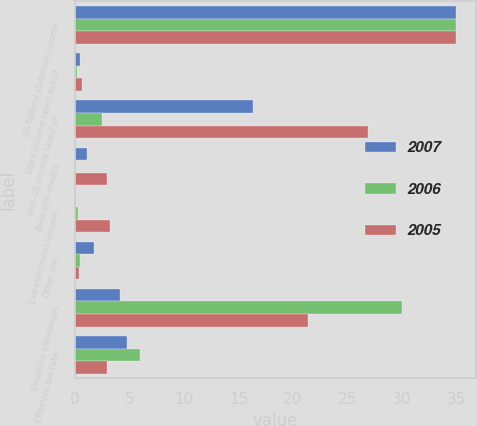Convert chart. <chart><loc_0><loc_0><loc_500><loc_500><stacked_bar_chart><ecel><fcel>US federal statutory income<fcel>State income taxes net of<fcel>Non-US income taxed at<fcel>Research credits<fcel>Extraterritorial income<fcel>Other net<fcel>Valuation allowances<fcel>Effective tax rate<nl><fcel>2007<fcel>35<fcel>0.5<fcel>16.3<fcel>1.1<fcel>0.1<fcel>1.7<fcel>4.1<fcel>4.8<nl><fcel>2006<fcel>35<fcel>0.2<fcel>2.5<fcel>0.1<fcel>0.3<fcel>0.5<fcel>30<fcel>6<nl><fcel>2005<fcel>35<fcel>0.6<fcel>26.9<fcel>2.9<fcel>3.2<fcel>0.4<fcel>21.4<fcel>2.9<nl></chart> 